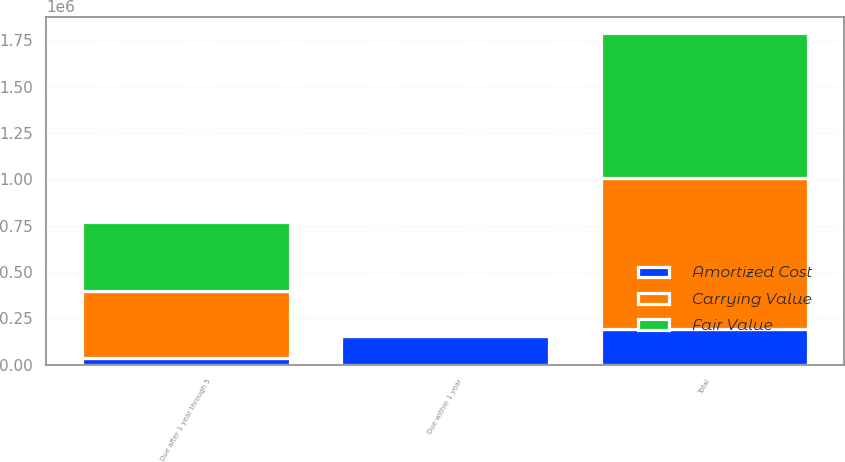Convert chart to OTSL. <chart><loc_0><loc_0><loc_500><loc_500><stacked_bar_chart><ecel><fcel>Due within 1 year<fcel>Due after 1 year through 5<fcel>Total<nl><fcel>Carrying Value<fcel>16103<fcel>361050<fcel>816161<nl><fcel>Fair Value<fcel>16196<fcel>370851<fcel>779855<nl><fcel>Amortized Cost<fcel>154000<fcel>37450<fcel>191450<nl></chart> 